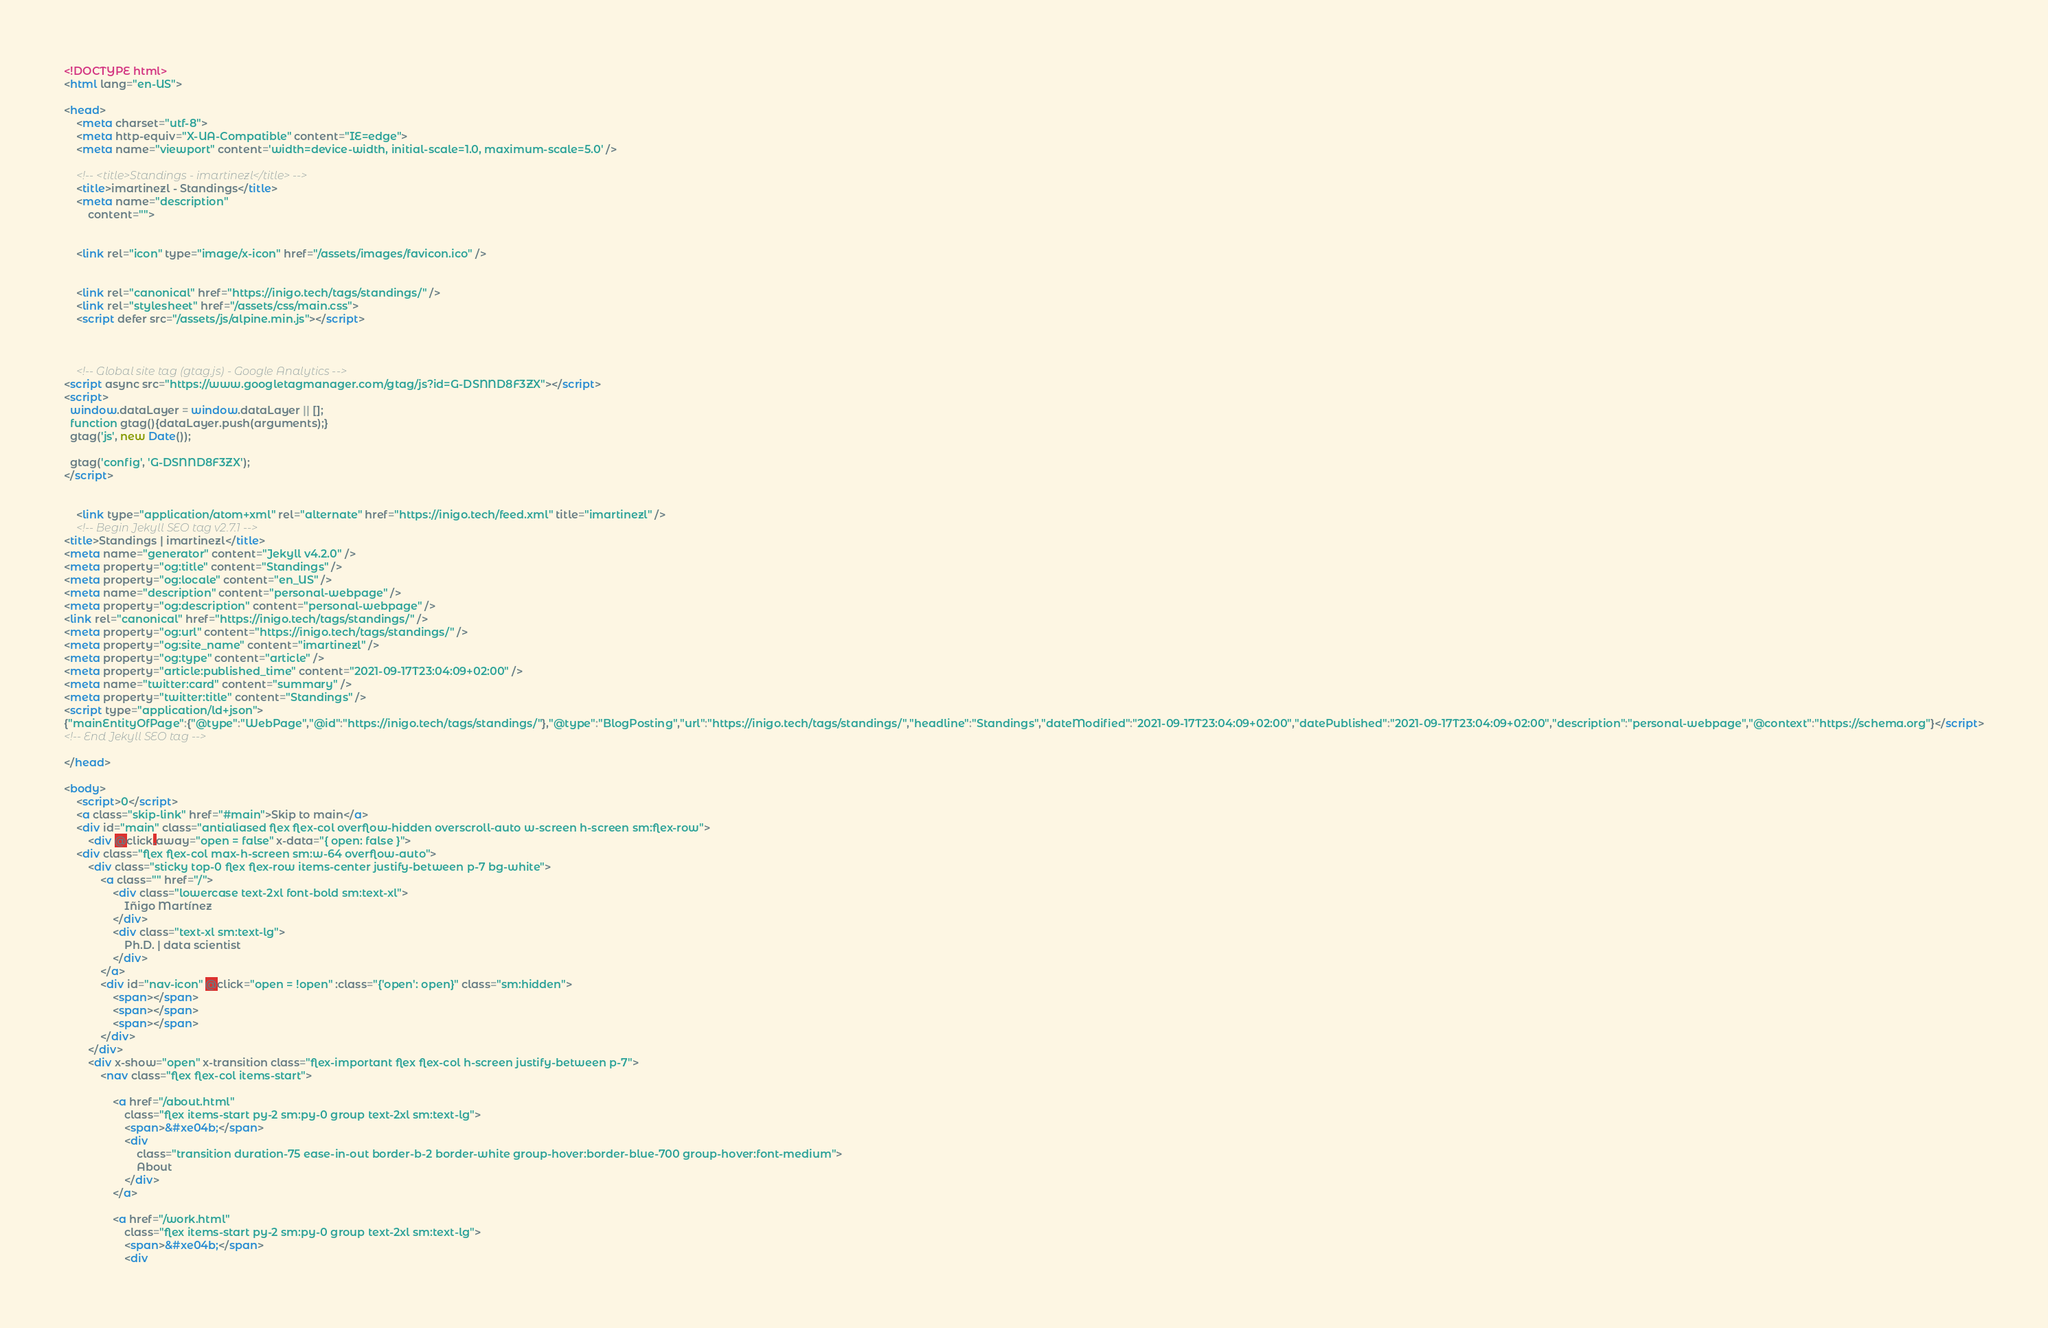Convert code to text. <code><loc_0><loc_0><loc_500><loc_500><_HTML_><!DOCTYPE html>
<html lang="en-US">

<head>
    <meta charset="utf-8">
    <meta http-equiv="X-UA-Compatible" content="IE=edge">
    <meta name="viewport" content='width=device-width, initial-scale=1.0, maximum-scale=5.0' />

    <!-- <title>Standings - imartinezl</title> -->
    <title>imartinezl - Standings</title>
    <meta name="description"
        content="">

    
    <link rel="icon" type="image/x-icon" href="/assets/images/favicon.ico" />
    

    <link rel="canonical" href="https://inigo.tech/tags/standings/" />
    <link rel="stylesheet" href="/assets/css/main.css">
    <script defer src="/assets/js/alpine.min.js"></script>


    
    <!-- Global site tag (gtag.js) - Google Analytics -->
<script async src="https://www.googletagmanager.com/gtag/js?id=G-DSNND8F3ZX"></script>
<script>
  window.dataLayer = window.dataLayer || [];
  function gtag(){dataLayer.push(arguments);}
  gtag('js', new Date());

  gtag('config', 'G-DSNND8F3ZX');
</script>
    

    <link type="application/atom+xml" rel="alternate" href="https://inigo.tech/feed.xml" title="imartinezl" />
    <!-- Begin Jekyll SEO tag v2.7.1 -->
<title>Standings | imartinezl</title>
<meta name="generator" content="Jekyll v4.2.0" />
<meta property="og:title" content="Standings" />
<meta property="og:locale" content="en_US" />
<meta name="description" content="personal-webpage" />
<meta property="og:description" content="personal-webpage" />
<link rel="canonical" href="https://inigo.tech/tags/standings/" />
<meta property="og:url" content="https://inigo.tech/tags/standings/" />
<meta property="og:site_name" content="imartinezl" />
<meta property="og:type" content="article" />
<meta property="article:published_time" content="2021-09-17T23:04:09+02:00" />
<meta name="twitter:card" content="summary" />
<meta property="twitter:title" content="Standings" />
<script type="application/ld+json">
{"mainEntityOfPage":{"@type":"WebPage","@id":"https://inigo.tech/tags/standings/"},"@type":"BlogPosting","url":"https://inigo.tech/tags/standings/","headline":"Standings","dateModified":"2021-09-17T23:04:09+02:00","datePublished":"2021-09-17T23:04:09+02:00","description":"personal-webpage","@context":"https://schema.org"}</script>
<!-- End Jekyll SEO tag -->

</head>

<body>
    <script>0</script>
    <a class="skip-link" href="#main">Skip to main</a>
    <div id="main" class="antialiased flex flex-col overflow-hidden overscroll-auto w-screen h-screen sm:flex-row">
        <div @click.away="open = false" x-data="{ open: false }">
    <div class="flex flex-col max-h-screen sm:w-64 overflow-auto">
        <div class="sticky top-0 flex flex-row items-center justify-between p-7 bg-white">
            <a class="" href="/">
                <div class="lowercase text-2xl font-bold sm:text-xl">
                    Iñigo Martínez
                </div>
                <div class="text-xl sm:text-lg">
                    Ph.D. | data scientist
                </div>
            </a>
            <div id="nav-icon" @click="open = !open" :class="{'open': open}" class="sm:hidden">
                <span></span>
                <span></span>
                <span></span>
            </div>
        </div>
        <div x-show="open" x-transition class="flex-important flex flex-col h-screen justify-between p-7">
            <nav class="flex flex-col items-start">
                
                <a href="/about.html" 
                    class="flex items-start py-2 sm:py-0 group text-2xl sm:text-lg">
                    <span>&#xe04b;</span>
                    <div 
                        class="transition duration-75 ease-in-out border-b-2 border-white group-hover:border-blue-700 group-hover:font-medium">
                        About
                    </div>
                </a>
                
                <a href="/work.html" 
                    class="flex items-start py-2 sm:py-0 group text-2xl sm:text-lg">
                    <span>&#xe04b;</span>
                    <div </code> 